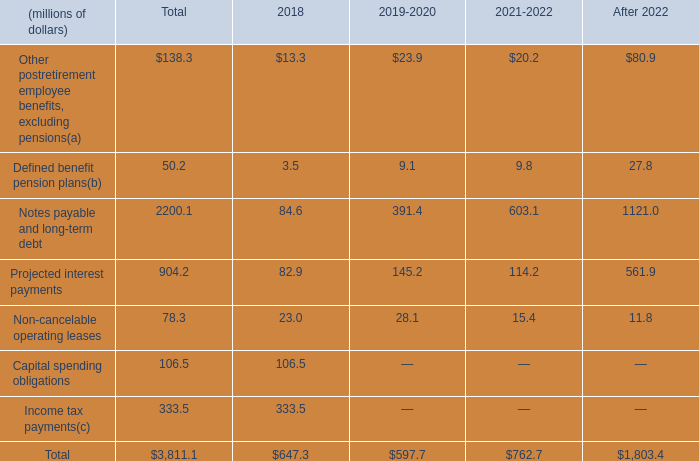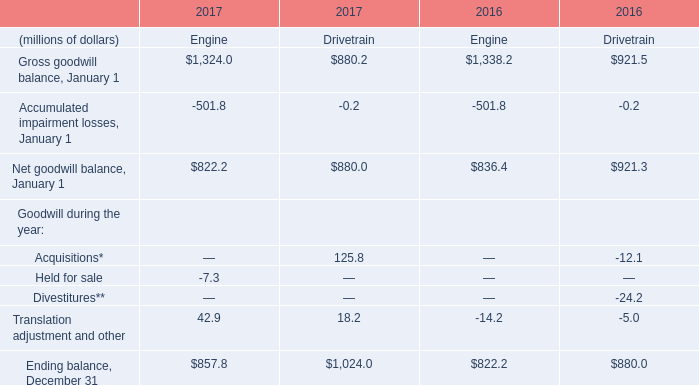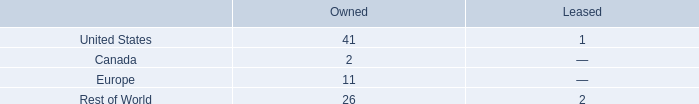What was the average of the Ending balance, December 31 in the years where Translation adjustment and other is positive? (in million) 
Computations: ((857.8 + 1024) / 2)
Answer: 940.9. 